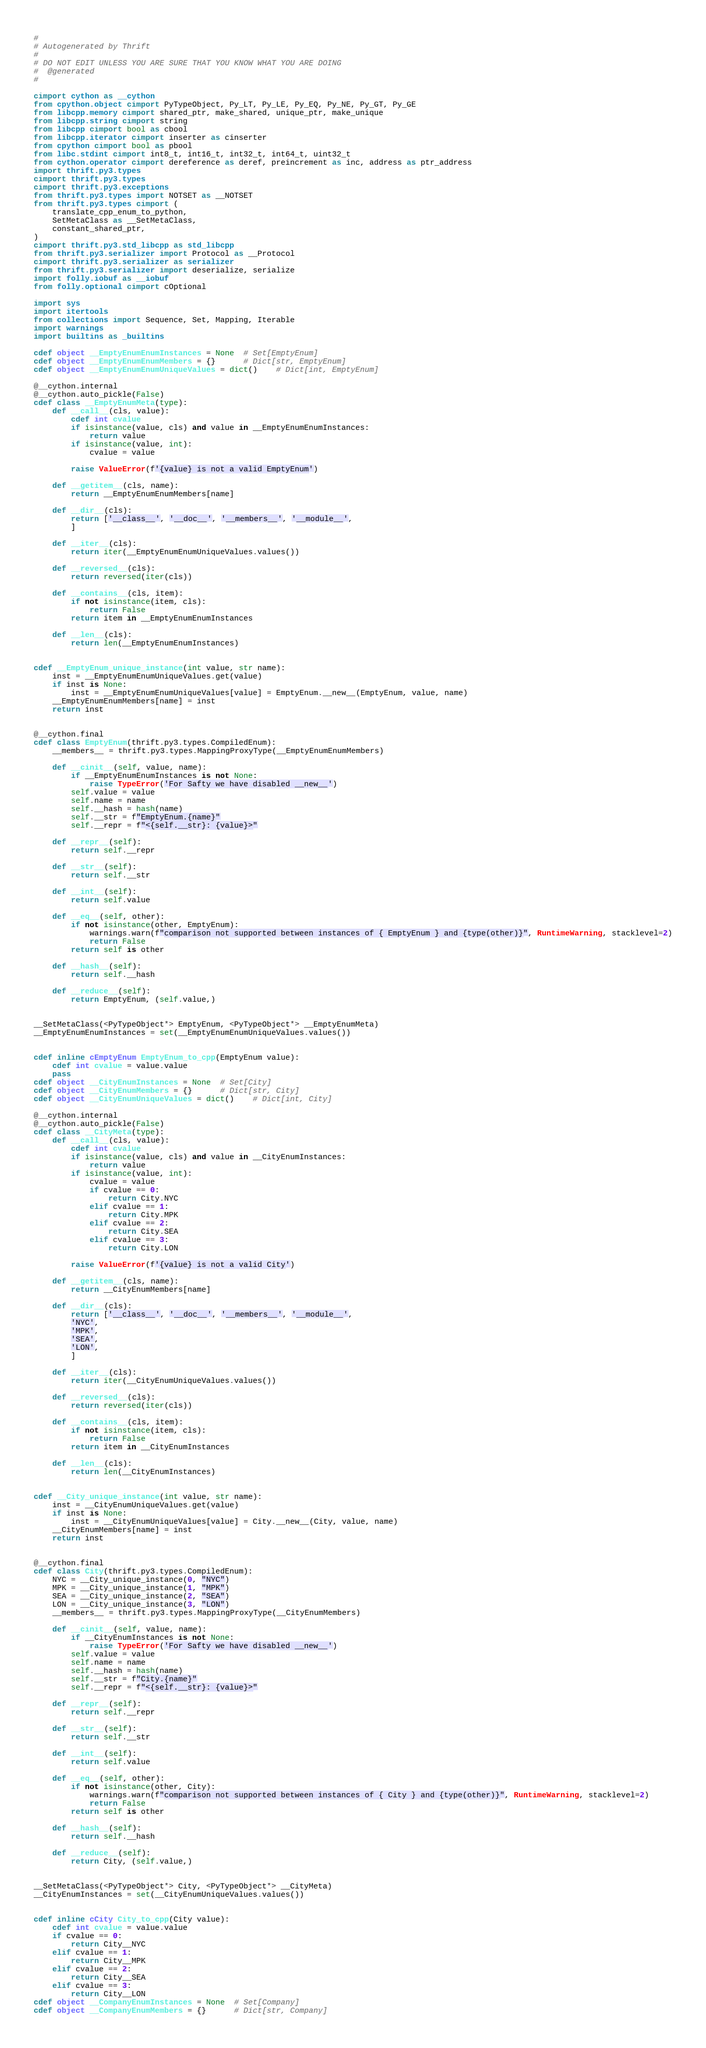<code> <loc_0><loc_0><loc_500><loc_500><_Cython_>#
# Autogenerated by Thrift
#
# DO NOT EDIT UNLESS YOU ARE SURE THAT YOU KNOW WHAT YOU ARE DOING
#  @generated
#

cimport cython as __cython
from cpython.object cimport PyTypeObject, Py_LT, Py_LE, Py_EQ, Py_NE, Py_GT, Py_GE
from libcpp.memory cimport shared_ptr, make_shared, unique_ptr, make_unique
from libcpp.string cimport string
from libcpp cimport bool as cbool
from libcpp.iterator cimport inserter as cinserter
from cpython cimport bool as pbool
from libc.stdint cimport int8_t, int16_t, int32_t, int64_t, uint32_t
from cython.operator cimport dereference as deref, preincrement as inc, address as ptr_address
import thrift.py3.types
cimport thrift.py3.types
cimport thrift.py3.exceptions
from thrift.py3.types import NOTSET as __NOTSET
from thrift.py3.types cimport (
    translate_cpp_enum_to_python,
    SetMetaClass as __SetMetaClass,
    constant_shared_ptr,
)
cimport thrift.py3.std_libcpp as std_libcpp
from thrift.py3.serializer import Protocol as __Protocol
cimport thrift.py3.serializer as serializer
from thrift.py3.serializer import deserialize, serialize
import folly.iobuf as __iobuf
from folly.optional cimport cOptional

import sys
import itertools
from collections import Sequence, Set, Mapping, Iterable
import warnings
import builtins as _builtins

cdef object __EmptyEnumEnumInstances = None  # Set[EmptyEnum]
cdef object __EmptyEnumEnumMembers = {}      # Dict[str, EmptyEnum]
cdef object __EmptyEnumEnumUniqueValues = dict()    # Dict[int, EmptyEnum]

@__cython.internal
@__cython.auto_pickle(False)
cdef class __EmptyEnumMeta(type):
    def __call__(cls, value):
        cdef int cvalue
        if isinstance(value, cls) and value in __EmptyEnumEnumInstances:
            return value
        if isinstance(value, int):
            cvalue = value

        raise ValueError(f'{value} is not a valid EmptyEnum')

    def __getitem__(cls, name):
        return __EmptyEnumEnumMembers[name]

    def __dir__(cls):
        return ['__class__', '__doc__', '__members__', '__module__',
        ]

    def __iter__(cls):
        return iter(__EmptyEnumEnumUniqueValues.values())

    def __reversed__(cls):
        return reversed(iter(cls))

    def __contains__(cls, item):
        if not isinstance(item, cls):
            return False
        return item in __EmptyEnumEnumInstances

    def __len__(cls):
        return len(__EmptyEnumEnumInstances)


cdef __EmptyEnum_unique_instance(int value, str name):
    inst = __EmptyEnumEnumUniqueValues.get(value)
    if inst is None:
        inst = __EmptyEnumEnumUniqueValues[value] = EmptyEnum.__new__(EmptyEnum, value, name)
    __EmptyEnumEnumMembers[name] = inst
    return inst


@__cython.final
cdef class EmptyEnum(thrift.py3.types.CompiledEnum):
    __members__ = thrift.py3.types.MappingProxyType(__EmptyEnumEnumMembers)

    def __cinit__(self, value, name):
        if __EmptyEnumEnumInstances is not None:
            raise TypeError('For Safty we have disabled __new__')
        self.value = value
        self.name = name
        self.__hash = hash(name)
        self.__str = f"EmptyEnum.{name}"
        self.__repr = f"<{self.__str}: {value}>"

    def __repr__(self):
        return self.__repr

    def __str__(self):
        return self.__str

    def __int__(self):
        return self.value

    def __eq__(self, other):
        if not isinstance(other, EmptyEnum):
            warnings.warn(f"comparison not supported between instances of { EmptyEnum } and {type(other)}", RuntimeWarning, stacklevel=2)
            return False
        return self is other

    def __hash__(self):
        return self.__hash

    def __reduce__(self):
        return EmptyEnum, (self.value,)


__SetMetaClass(<PyTypeObject*> EmptyEnum, <PyTypeObject*> __EmptyEnumMeta)
__EmptyEnumEnumInstances = set(__EmptyEnumEnumUniqueValues.values())


cdef inline cEmptyEnum EmptyEnum_to_cpp(EmptyEnum value):
    cdef int cvalue = value.value
    pass
cdef object __CityEnumInstances = None  # Set[City]
cdef object __CityEnumMembers = {}      # Dict[str, City]
cdef object __CityEnumUniqueValues = dict()    # Dict[int, City]

@__cython.internal
@__cython.auto_pickle(False)
cdef class __CityMeta(type):
    def __call__(cls, value):
        cdef int cvalue
        if isinstance(value, cls) and value in __CityEnumInstances:
            return value
        if isinstance(value, int):
            cvalue = value
            if cvalue == 0:
                return City.NYC
            elif cvalue == 1:
                return City.MPK
            elif cvalue == 2:
                return City.SEA
            elif cvalue == 3:
                return City.LON

        raise ValueError(f'{value} is not a valid City')

    def __getitem__(cls, name):
        return __CityEnumMembers[name]

    def __dir__(cls):
        return ['__class__', '__doc__', '__members__', '__module__',
        'NYC',
        'MPK',
        'SEA',
        'LON',
        ]

    def __iter__(cls):
        return iter(__CityEnumUniqueValues.values())

    def __reversed__(cls):
        return reversed(iter(cls))

    def __contains__(cls, item):
        if not isinstance(item, cls):
            return False
        return item in __CityEnumInstances

    def __len__(cls):
        return len(__CityEnumInstances)


cdef __City_unique_instance(int value, str name):
    inst = __CityEnumUniqueValues.get(value)
    if inst is None:
        inst = __CityEnumUniqueValues[value] = City.__new__(City, value, name)
    __CityEnumMembers[name] = inst
    return inst


@__cython.final
cdef class City(thrift.py3.types.CompiledEnum):
    NYC = __City_unique_instance(0, "NYC")
    MPK = __City_unique_instance(1, "MPK")
    SEA = __City_unique_instance(2, "SEA")
    LON = __City_unique_instance(3, "LON")
    __members__ = thrift.py3.types.MappingProxyType(__CityEnumMembers)

    def __cinit__(self, value, name):
        if __CityEnumInstances is not None:
            raise TypeError('For Safty we have disabled __new__')
        self.value = value
        self.name = name
        self.__hash = hash(name)
        self.__str = f"City.{name}"
        self.__repr = f"<{self.__str}: {value}>"

    def __repr__(self):
        return self.__repr

    def __str__(self):
        return self.__str

    def __int__(self):
        return self.value

    def __eq__(self, other):
        if not isinstance(other, City):
            warnings.warn(f"comparison not supported between instances of { City } and {type(other)}", RuntimeWarning, stacklevel=2)
            return False
        return self is other

    def __hash__(self):
        return self.__hash

    def __reduce__(self):
        return City, (self.value,)


__SetMetaClass(<PyTypeObject*> City, <PyTypeObject*> __CityMeta)
__CityEnumInstances = set(__CityEnumUniqueValues.values())


cdef inline cCity City_to_cpp(City value):
    cdef int cvalue = value.value
    if cvalue == 0:
        return City__NYC
    elif cvalue == 1:
        return City__MPK
    elif cvalue == 2:
        return City__SEA
    elif cvalue == 3:
        return City__LON
cdef object __CompanyEnumInstances = None  # Set[Company]
cdef object __CompanyEnumMembers = {}      # Dict[str, Company]</code> 